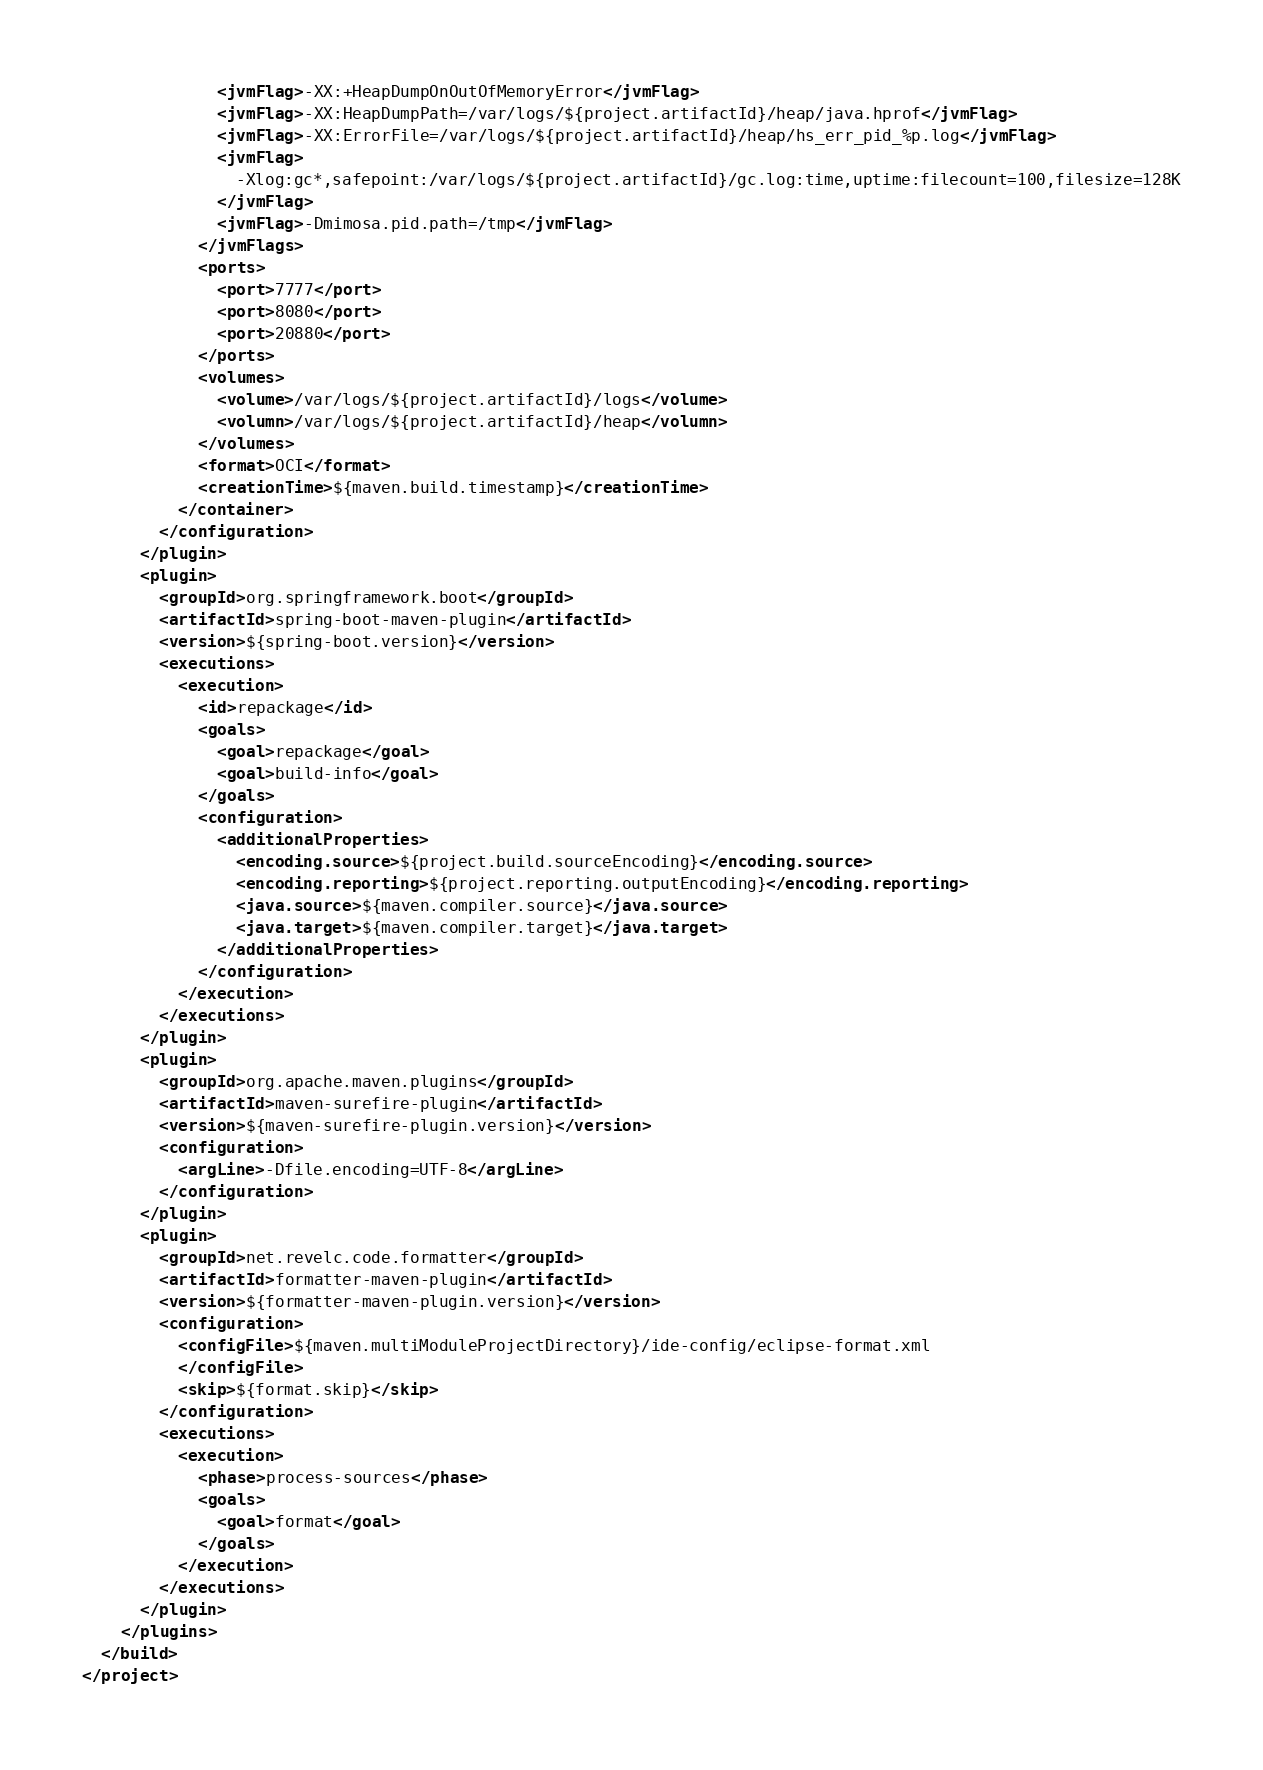Convert code to text. <code><loc_0><loc_0><loc_500><loc_500><_XML_>              <jvmFlag>-XX:+HeapDumpOnOutOfMemoryError</jvmFlag>
              <jvmFlag>-XX:HeapDumpPath=/var/logs/${project.artifactId}/heap/java.hprof</jvmFlag>
              <jvmFlag>-XX:ErrorFile=/var/logs/${project.artifactId}/heap/hs_err_pid_%p.log</jvmFlag>
              <jvmFlag>
                -Xlog:gc*,safepoint:/var/logs/${project.artifactId}/gc.log:time,uptime:filecount=100,filesize=128K
              </jvmFlag>
              <jvmFlag>-Dmimosa.pid.path=/tmp</jvmFlag>
            </jvmFlags>
            <ports>
              <port>7777</port>
              <port>8080</port>
              <port>20880</port>
            </ports>
            <volumes>
              <volume>/var/logs/${project.artifactId}/logs</volume>
              <volumn>/var/logs/${project.artifactId}/heap</volumn>
            </volumes>
            <format>OCI</format>
            <creationTime>${maven.build.timestamp}</creationTime>
          </container>
        </configuration>
      </plugin>
      <plugin>
        <groupId>org.springframework.boot</groupId>
        <artifactId>spring-boot-maven-plugin</artifactId>
        <version>${spring-boot.version}</version>
        <executions>
          <execution>
            <id>repackage</id>
            <goals>
              <goal>repackage</goal>
              <goal>build-info</goal>
            </goals>
            <configuration>
              <additionalProperties>
                <encoding.source>${project.build.sourceEncoding}</encoding.source>
                <encoding.reporting>${project.reporting.outputEncoding}</encoding.reporting>
                <java.source>${maven.compiler.source}</java.source>
                <java.target>${maven.compiler.target}</java.target>
              </additionalProperties>
            </configuration>
          </execution>
        </executions>
      </plugin>
      <plugin>
        <groupId>org.apache.maven.plugins</groupId>
        <artifactId>maven-surefire-plugin</artifactId>
        <version>${maven-surefire-plugin.version}</version>
        <configuration>
          <argLine>-Dfile.encoding=UTF-8</argLine>
        </configuration>
      </plugin>
      <plugin>
        <groupId>net.revelc.code.formatter</groupId>
        <artifactId>formatter-maven-plugin</artifactId>
        <version>${formatter-maven-plugin.version}</version>
        <configuration>
          <configFile>${maven.multiModuleProjectDirectory}/ide-config/eclipse-format.xml
          </configFile>
          <skip>${format.skip}</skip>
        </configuration>
        <executions>
          <execution>
            <phase>process-sources</phase>
            <goals>
              <goal>format</goal>
            </goals>
          </execution>
        </executions>
      </plugin>
    </plugins>
  </build>
</project>

</code> 